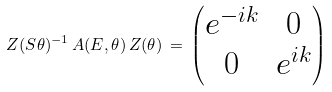Convert formula to latex. <formula><loc_0><loc_0><loc_500><loc_500>Z ( S \theta ) ^ { - 1 } \, A ( E , \theta ) \, Z ( \theta ) \, = \, \left ( \begin{matrix} e ^ { - i k } & 0 \\ 0 & e ^ { i k } \end{matrix} \right )</formula> 